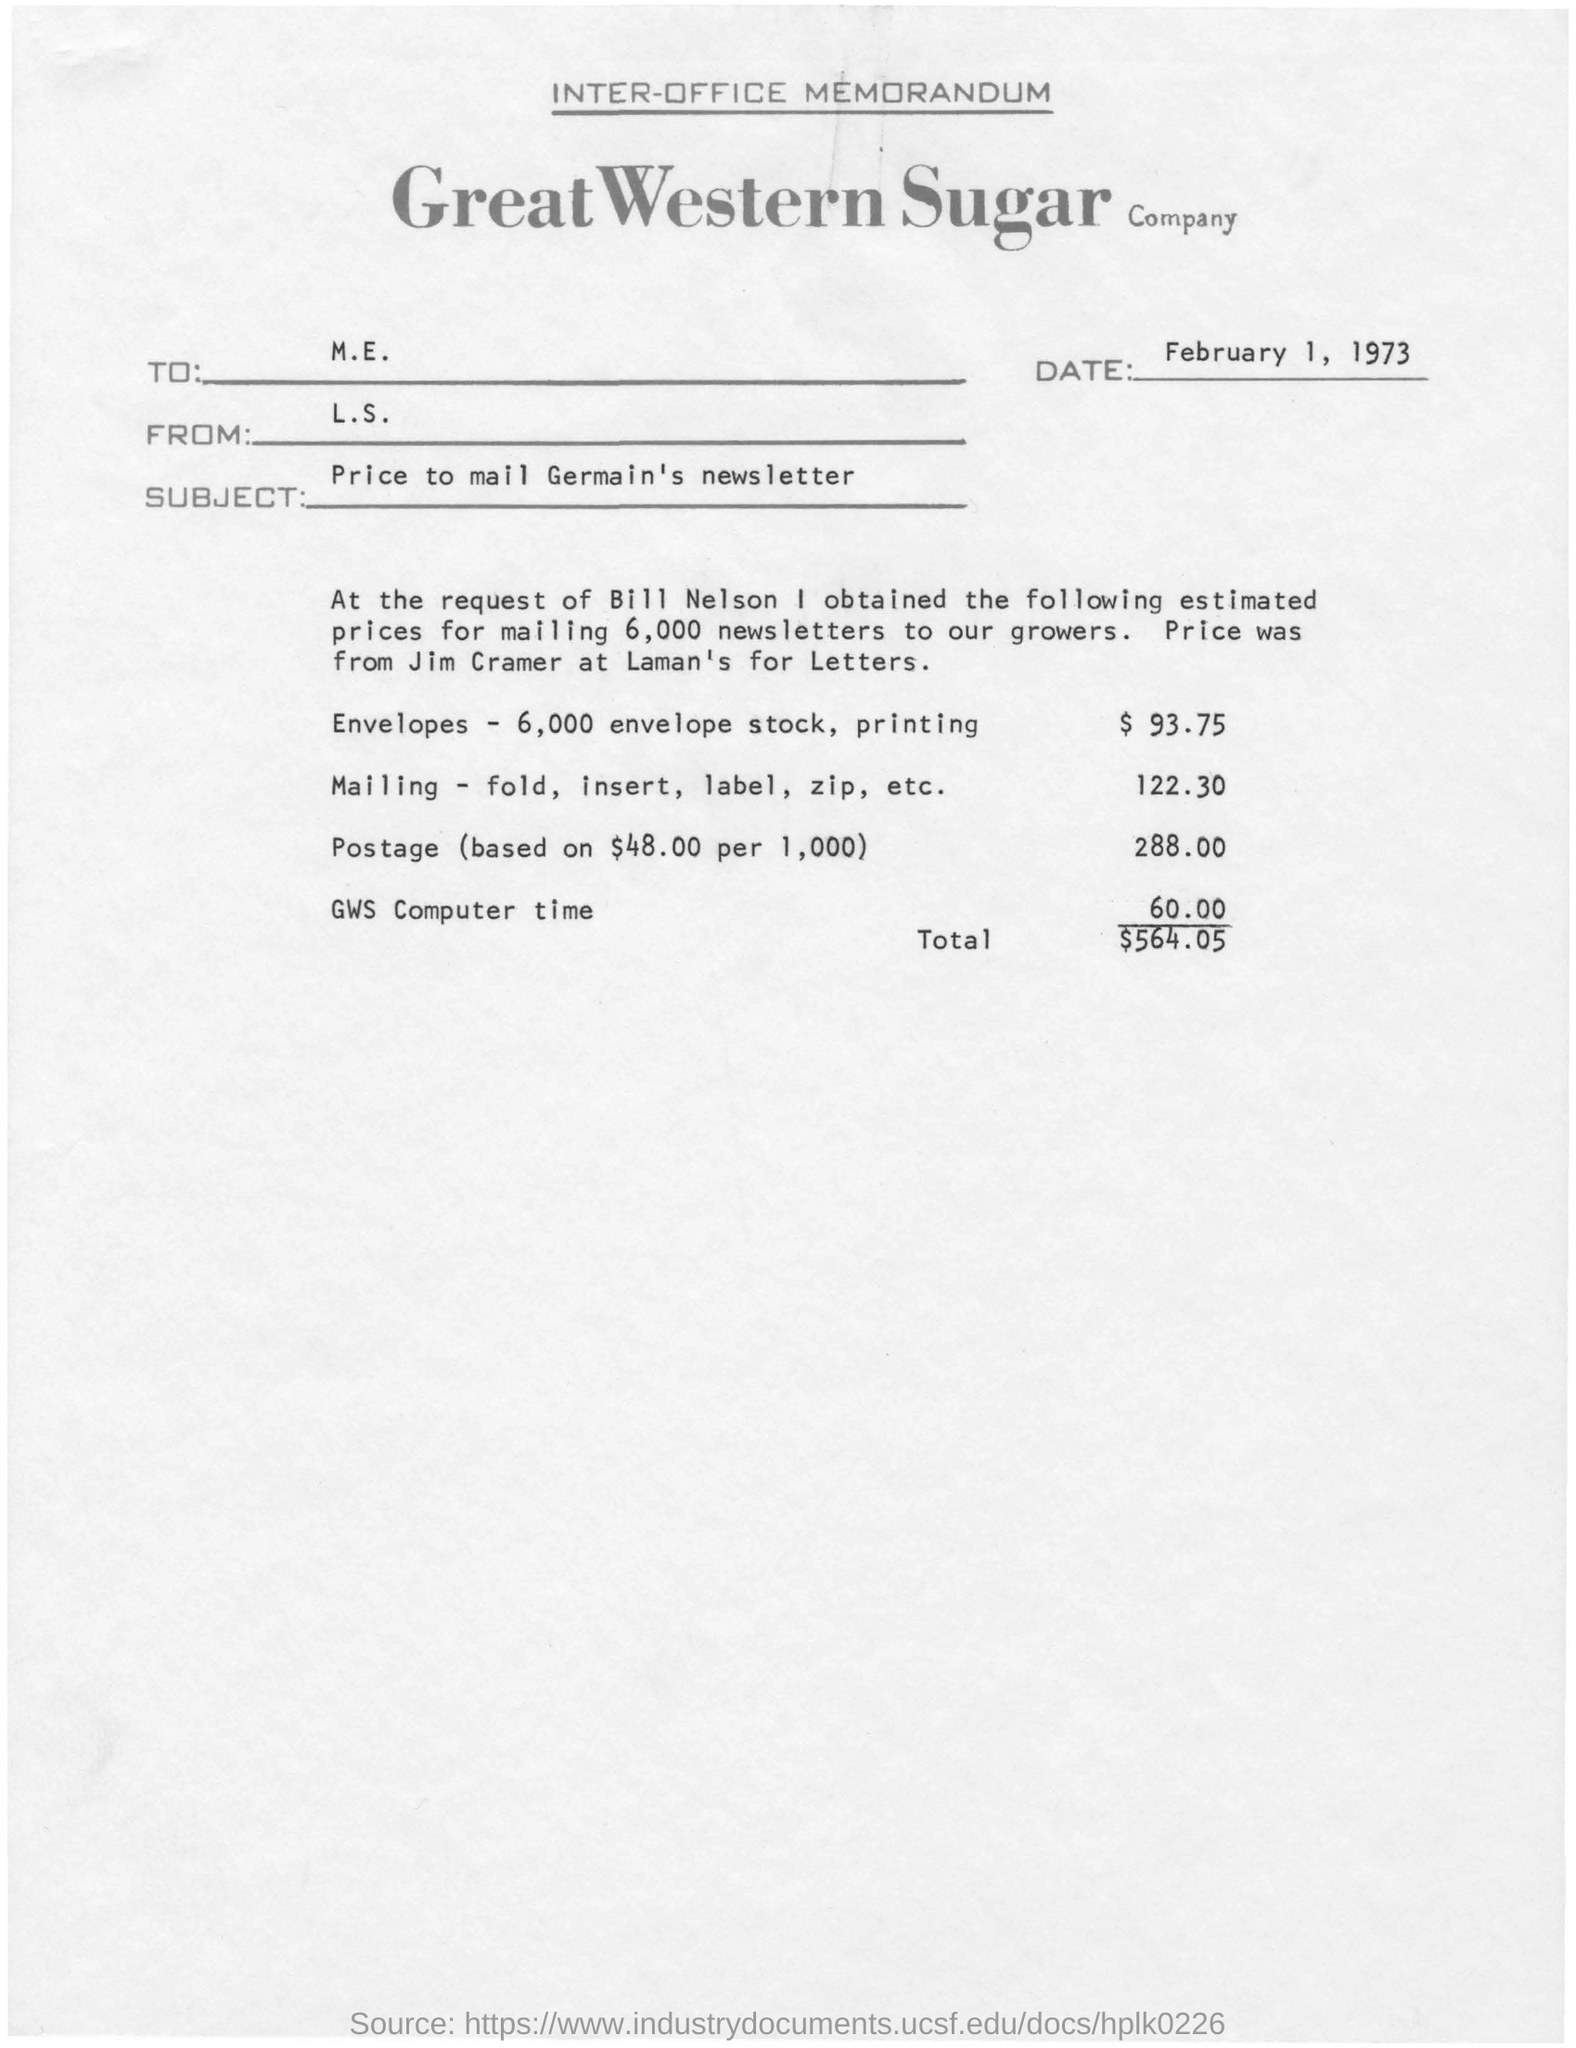Outline some significant characteristics in this image. The memorandum states that the date is February 1, 1973. The subject mentioned in the memorandum is the price for mailing Germain's newsletter. The "total" listed is $564.05. 